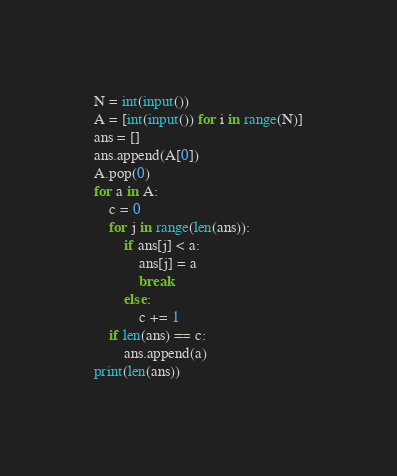<code> <loc_0><loc_0><loc_500><loc_500><_Python_>N = int(input())
A = [int(input()) for i in range(N)]
ans = []
ans.append(A[0])
A.pop(0)
for a in A:
    c = 0
    for j in range(len(ans)):
        if ans[j] < a:
            ans[j] = a
            break
        else:
            c += 1
    if len(ans) == c:
        ans.append(a)
print(len(ans))
</code> 